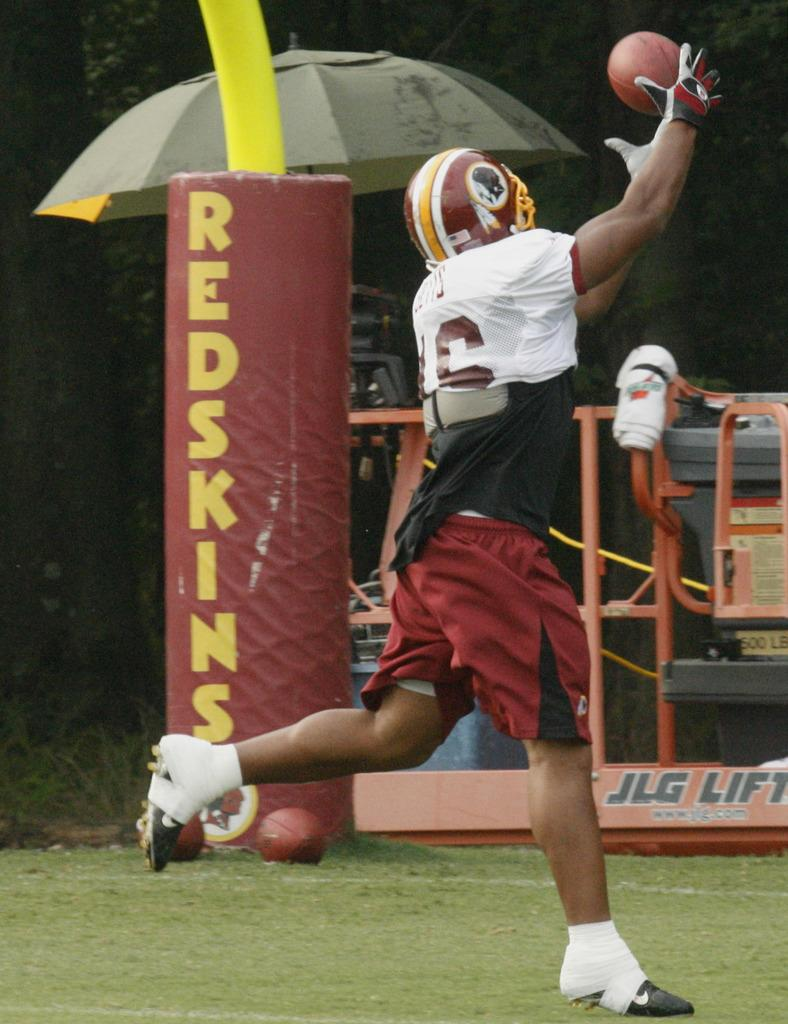What is the person in the image doing? The person is running in the image. What is the person doing while running? The person is catching a ball in the air. What can be seen in the background of the image? There are objects and trees in the background of the image. What type of cheese is being used for the activity in the image? There is no cheese present in the image, and no activity involving cheese is depicted. 